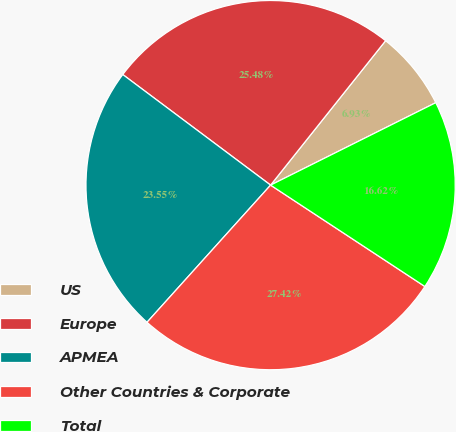<chart> <loc_0><loc_0><loc_500><loc_500><pie_chart><fcel>US<fcel>Europe<fcel>APMEA<fcel>Other Countries & Corporate<fcel>Total<nl><fcel>6.93%<fcel>25.48%<fcel>23.55%<fcel>27.42%<fcel>16.62%<nl></chart> 